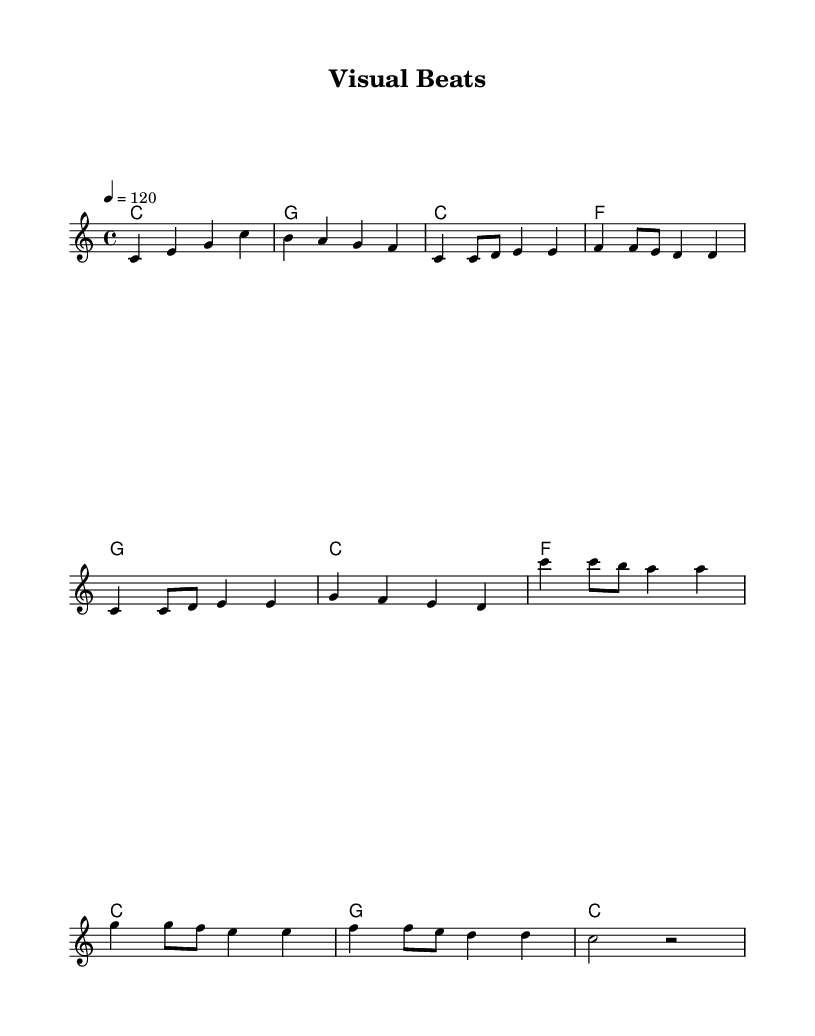what is the key signature of this music? The key signature is C major, which has no sharps or flats.
Answer: C major what is the time signature of this music? The time signature indicates there are 4 beats in a measure, denoted by 4/4.
Answer: 4/4 what is the tempo of this piece? The tempo is marked at 120 beats per minute, shown by the notation "4 = 120".
Answer: 120 what is the first note of the melody? The first note of the melody is C, which is the starting note in the introduction.
Answer: C in which section does the music modulate from the key of C major? The progression goes through different chords, but it stays primarily in C major without modulation to another key throughout the piece.
Answer: No modulation how many measures are in the chorus section? The chorus consists of 4 measures as shown in the repeated structure of the chords and melody.
Answer: 4 measures what chord follows the introduction in the verse section? The chord that follows after the introduction is F, continuing the chord progression in the verse.
Answer: F 